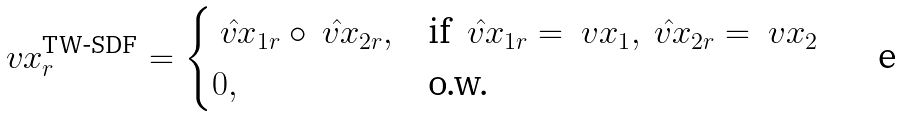Convert formula to latex. <formula><loc_0><loc_0><loc_500><loc_500>\ v x _ { r } ^ { \text {TW-SDF} } = \begin{cases} \hat { \ v x } _ { 1 r } \circ \hat { \ v x } _ { 2 r } , & \text {if } \hat { \ v x } _ { 1 r } = \ v x _ { 1 } , \hat { \ v x } _ { 2 r } = \ v x _ { 2 } \\ 0 , & \text {o.w.} \end{cases}</formula> 